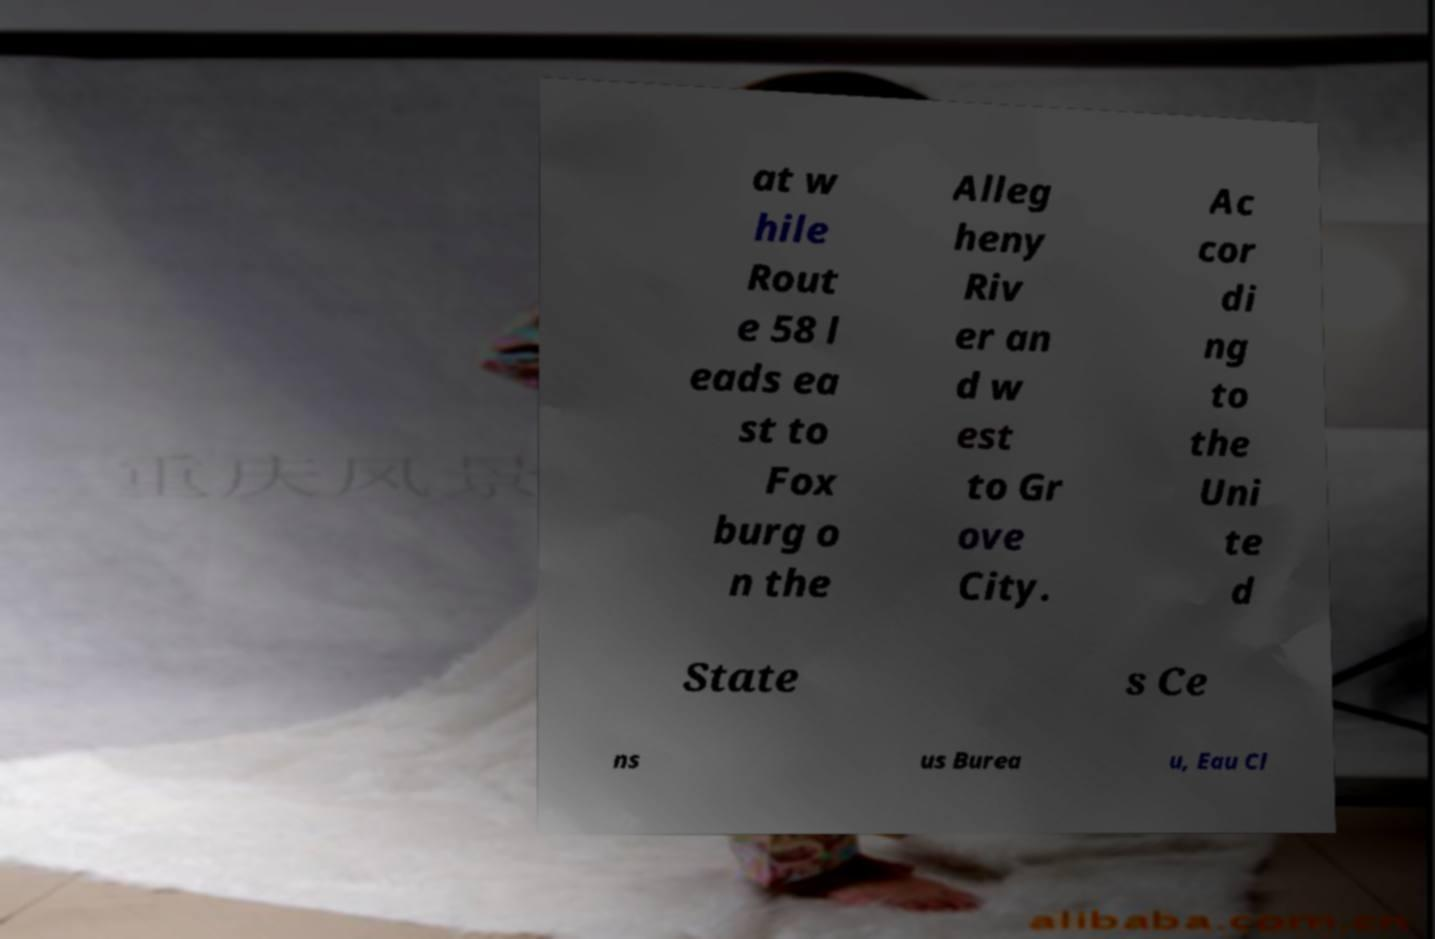For documentation purposes, I need the text within this image transcribed. Could you provide that? at w hile Rout e 58 l eads ea st to Fox burg o n the Alleg heny Riv er an d w est to Gr ove City. Ac cor di ng to the Uni te d State s Ce ns us Burea u, Eau Cl 